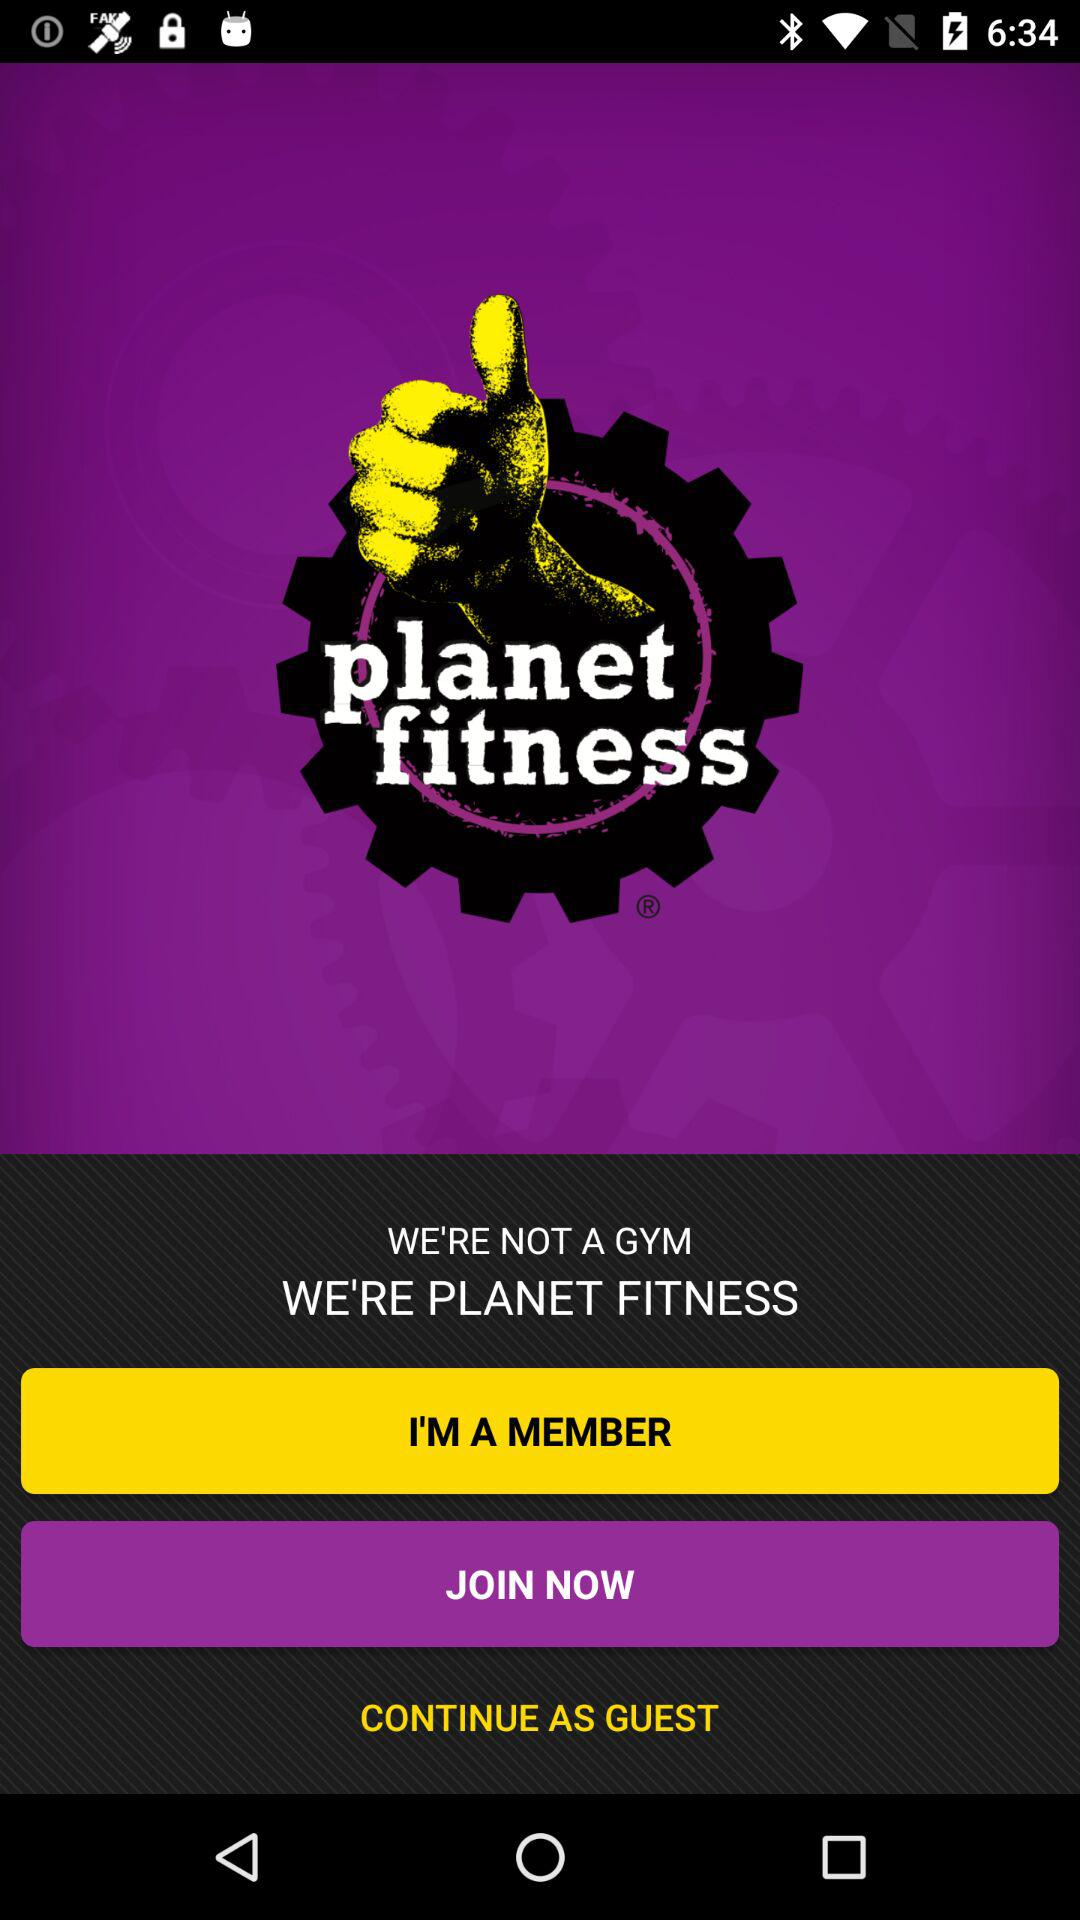What is the application name? The application name is "planet fitness". 